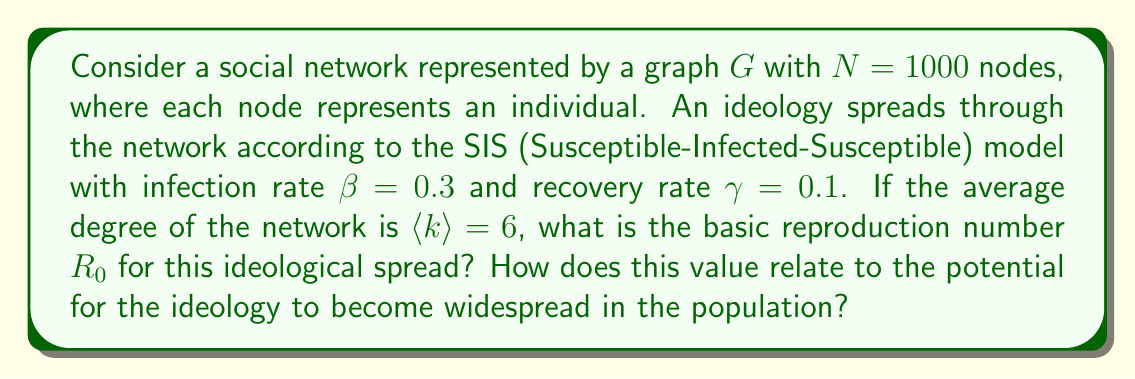Provide a solution to this math problem. To solve this problem, we'll follow these steps:

1) In network theory, the basic reproduction number $R_0$ for the SIS model on a network is given by:

   $$R_0 = \frac{\beta \langle k \rangle}{\gamma}$$

   Where:
   - $\beta$ is the infection rate
   - $\langle k \rangle$ is the average degree of the network
   - $\gamma$ is the recovery rate

2) We're given:
   - $\beta = 0.3$
   - $\gamma = 0.1$
   - $\langle k \rangle = 6$

3) Let's substitute these values into the equation:

   $$R_0 = \frac{0.3 \times 6}{0.1} = \frac{1.8}{0.1} = 18$$

4) Interpreting the result:
   - If $R_0 > 1$, the ideology has the potential to spread and persist in the population.
   - If $R_0 < 1$, the ideology is likely to die out.

5) In this case, $R_0 = 18$, which is significantly greater than 1. This indicates that the ideology has a high potential to become widespread in the population.

6) The value of 18 means that, on average, each "infected" individual (someone who has adopted the ideology) will spread it to 18 others before recovering (abandoning the ideology).
Answer: $R_0 = 18$; high potential for widespread adoption 